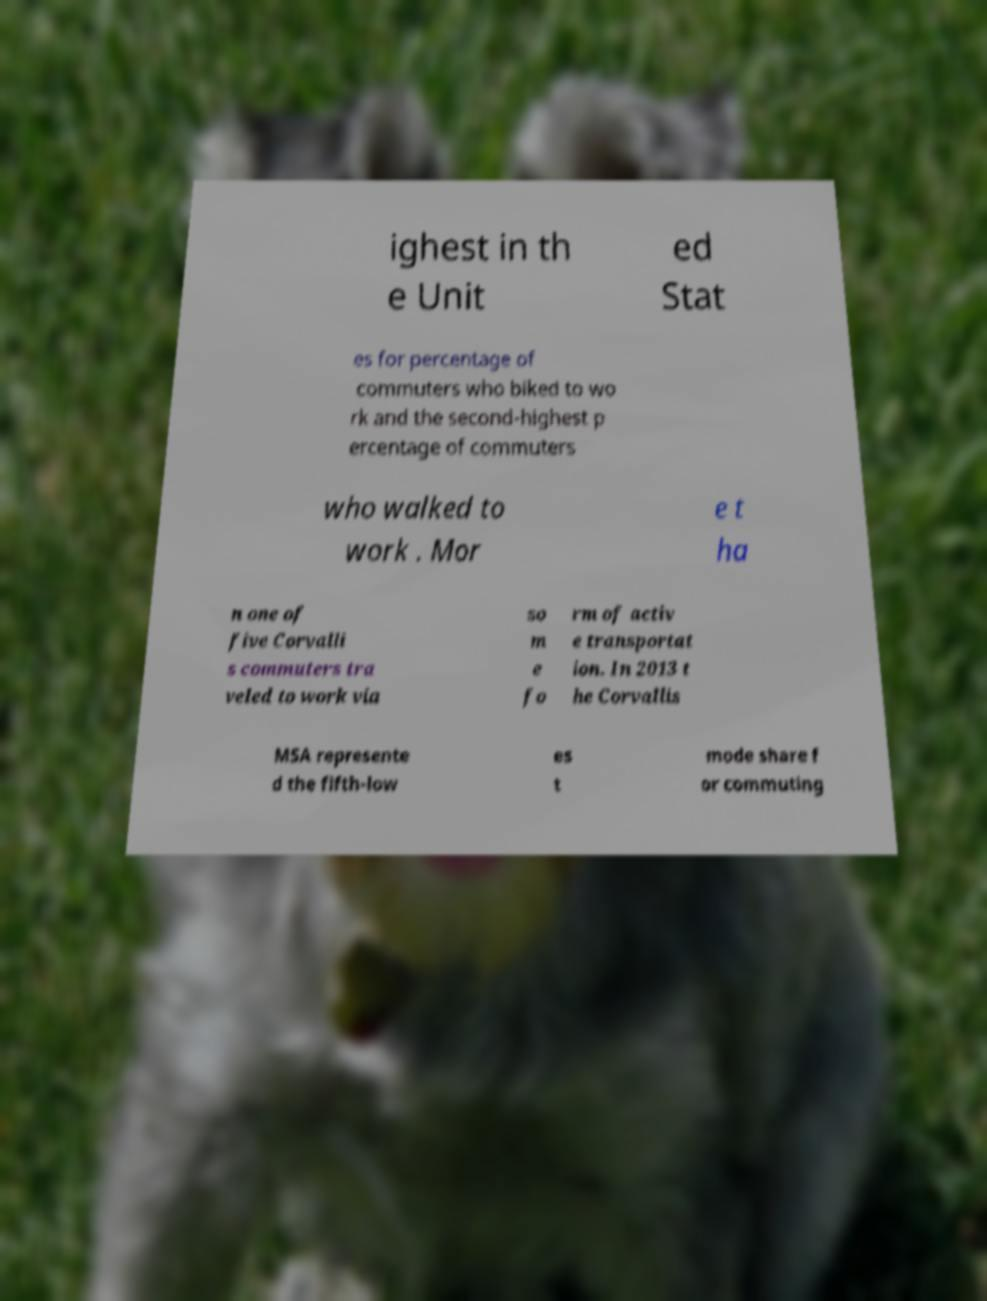Please identify and transcribe the text found in this image. ighest in th e Unit ed Stat es for percentage of commuters who biked to wo rk and the second-highest p ercentage of commuters who walked to work . Mor e t ha n one of five Corvalli s commuters tra veled to work via so m e fo rm of activ e transportat ion. In 2013 t he Corvallis MSA represente d the fifth-low es t mode share f or commuting 